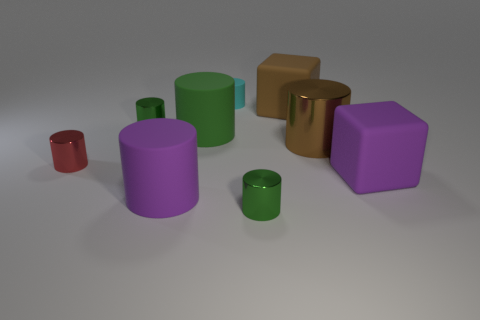Add 1 big purple blocks. How many objects exist? 10 Add 8 small green shiny objects. How many small green shiny objects are left? 10 Add 9 big green cylinders. How many big green cylinders exist? 10 Subtract all brown cylinders. How many cylinders are left? 6 Subtract all large green cylinders. How many cylinders are left? 6 Subtract 0 yellow blocks. How many objects are left? 9 Subtract all cylinders. How many objects are left? 2 Subtract 1 blocks. How many blocks are left? 1 Subtract all brown cubes. Subtract all green cylinders. How many cubes are left? 1 Subtract all gray balls. How many purple cubes are left? 1 